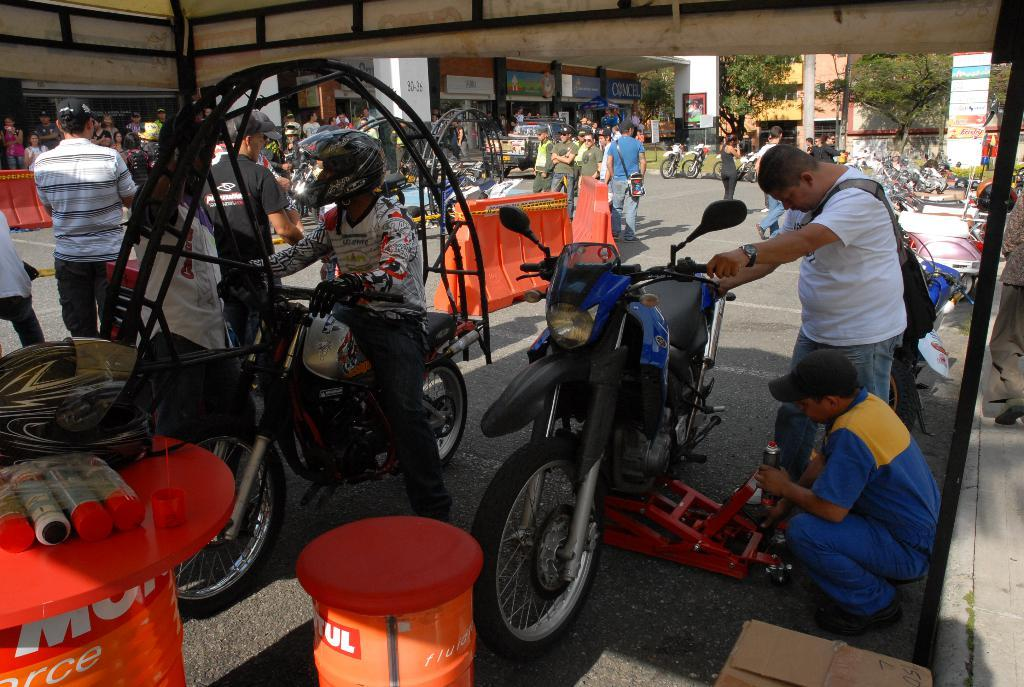What are the people in the image doing? There are people standing and people sitting on a bike in the image. What might the people on the bike be doing? The people on the bike are serving it, possibly repairing or maintaining it. What type of furniture can be seen in the image? There is no furniture present in the image. What is the opinion of the stranger in the image about the bike? There is no stranger present in the image, so it is not possible to determine their opinion about the bike. 